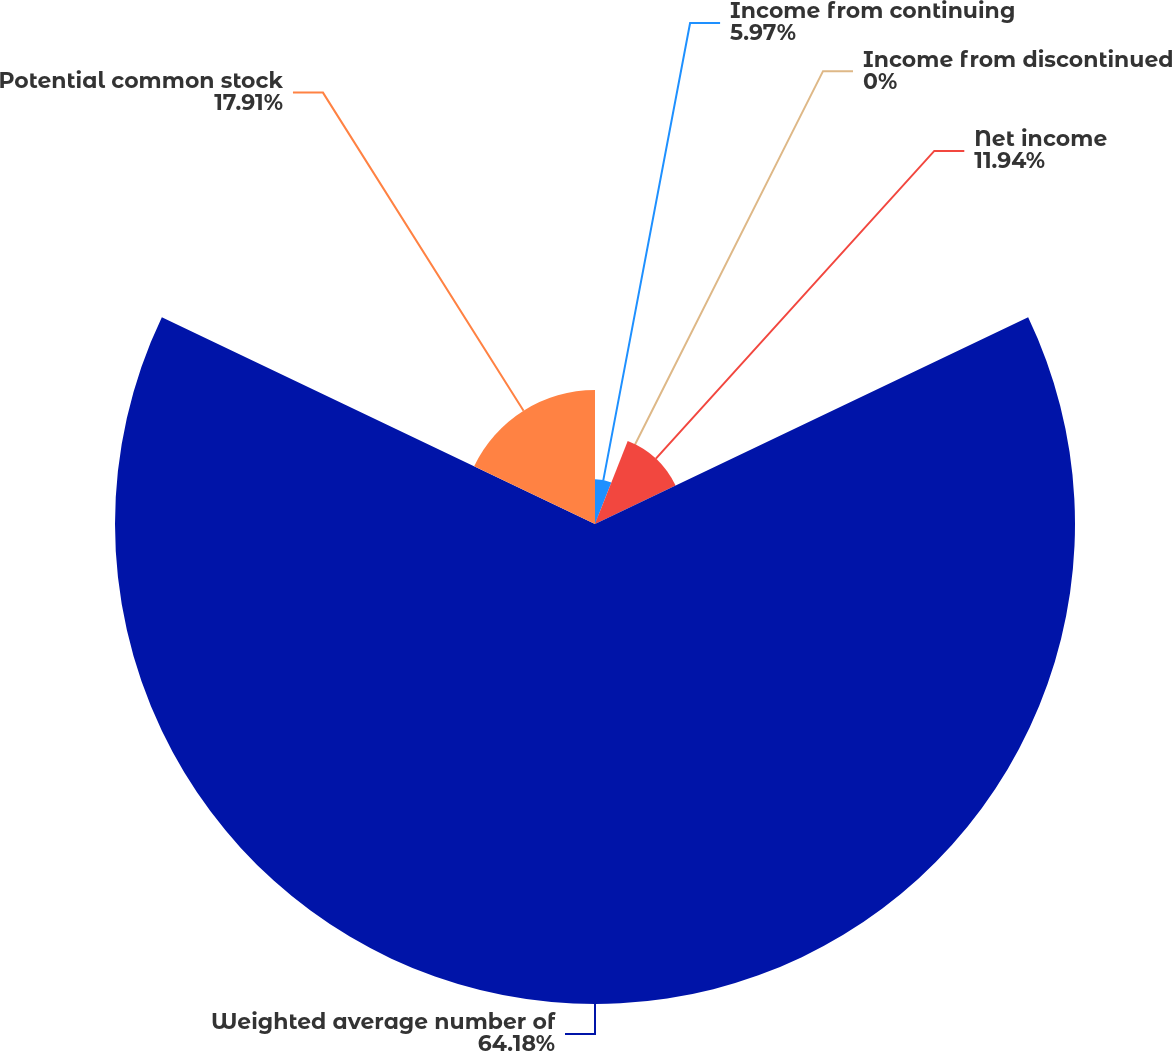<chart> <loc_0><loc_0><loc_500><loc_500><pie_chart><fcel>Income from continuing<fcel>Income from discontinued<fcel>Net income<fcel>Weighted average number of<fcel>Potential common stock<nl><fcel>5.97%<fcel>0.0%<fcel>11.94%<fcel>64.18%<fcel>17.91%<nl></chart> 